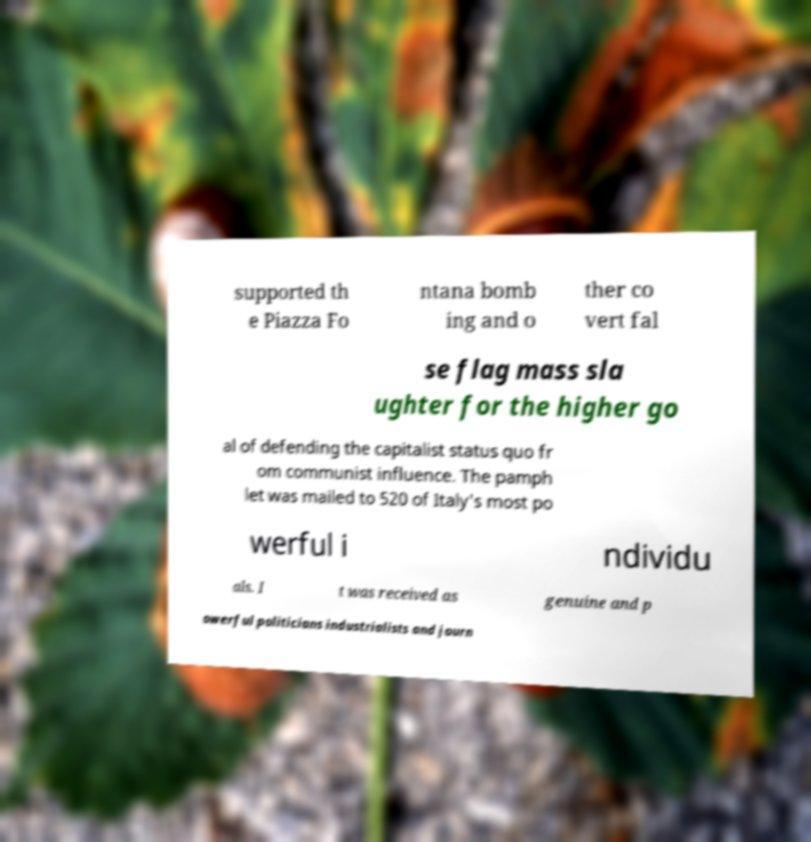I need the written content from this picture converted into text. Can you do that? supported th e Piazza Fo ntana bomb ing and o ther co vert fal se flag mass sla ughter for the higher go al of defending the capitalist status quo fr om communist influence. The pamph let was mailed to 520 of Italy's most po werful i ndividu als. I t was received as genuine and p owerful politicians industrialists and journ 